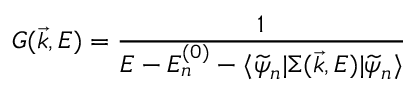<formula> <loc_0><loc_0><loc_500><loc_500>G ( \vec { k } , E ) = \frac { 1 } { E - E _ { n } ^ { ( 0 ) } - \langle \widetilde { \psi } _ { n } | \Sigma ( \vec { k } , E ) | \widetilde { \psi } _ { n } \rangle }</formula> 